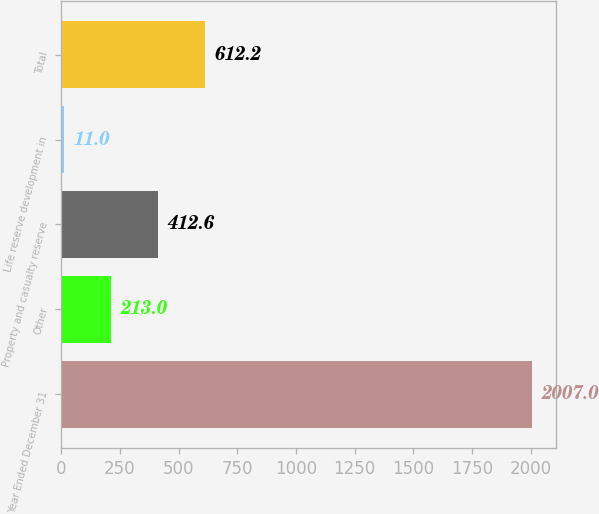Convert chart to OTSL. <chart><loc_0><loc_0><loc_500><loc_500><bar_chart><fcel>Year Ended December 31<fcel>Other<fcel>Property and casualty reserve<fcel>Life reserve development in<fcel>Total<nl><fcel>2007<fcel>213<fcel>412.6<fcel>11<fcel>612.2<nl></chart> 